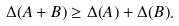Convert formula to latex. <formula><loc_0><loc_0><loc_500><loc_500>\Delta ( A + B ) \geq \Delta ( A ) + \Delta ( B ) .</formula> 